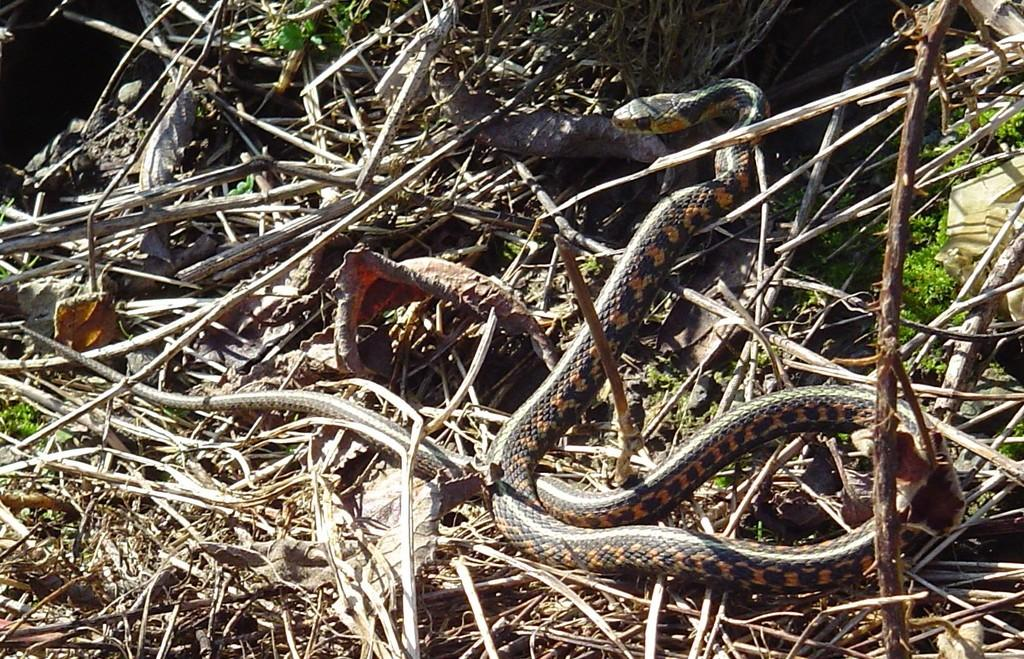What type of animal can be seen in the image? There is a snake in the image. What type of vegetation is present in the image? There is grass in the image. What type of mist can be seen surrounding the star in the image? There is no mist or star present in the image; it features a snake and grass. 